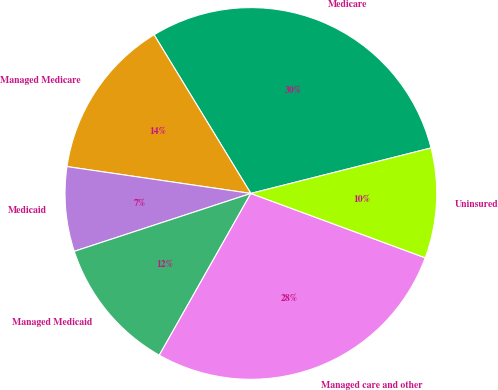Convert chart to OTSL. <chart><loc_0><loc_0><loc_500><loc_500><pie_chart><fcel>Medicare<fcel>Managed Medicare<fcel>Medicaid<fcel>Managed Medicaid<fcel>Managed care and other<fcel>Uninsured<nl><fcel>29.78%<fcel>13.97%<fcel>7.35%<fcel>11.76%<fcel>27.57%<fcel>9.56%<nl></chart> 